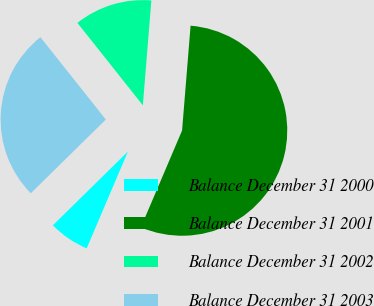Convert chart. <chart><loc_0><loc_0><loc_500><loc_500><pie_chart><fcel>Balance December 31 2000<fcel>Balance December 31 2001<fcel>Balance December 31 2002<fcel>Balance December 31 2003<nl><fcel>6.23%<fcel>55.11%<fcel>11.97%<fcel>26.68%<nl></chart> 